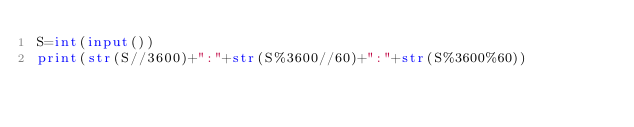<code> <loc_0><loc_0><loc_500><loc_500><_Python_>S=int(input())
print(str(S//3600)+":"+str(S%3600//60)+":"+str(S%3600%60))</code> 